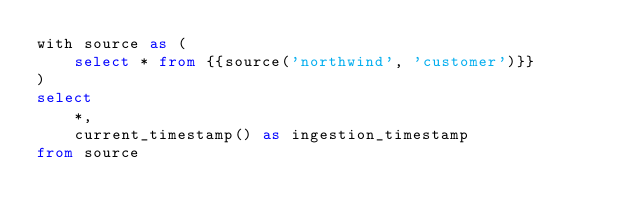Convert code to text. <code><loc_0><loc_0><loc_500><loc_500><_SQL_>with source as (
    select * from {{source('northwind', 'customer')}}
)
select 
    *,
    current_timestamp() as ingestion_timestamp
from source</code> 